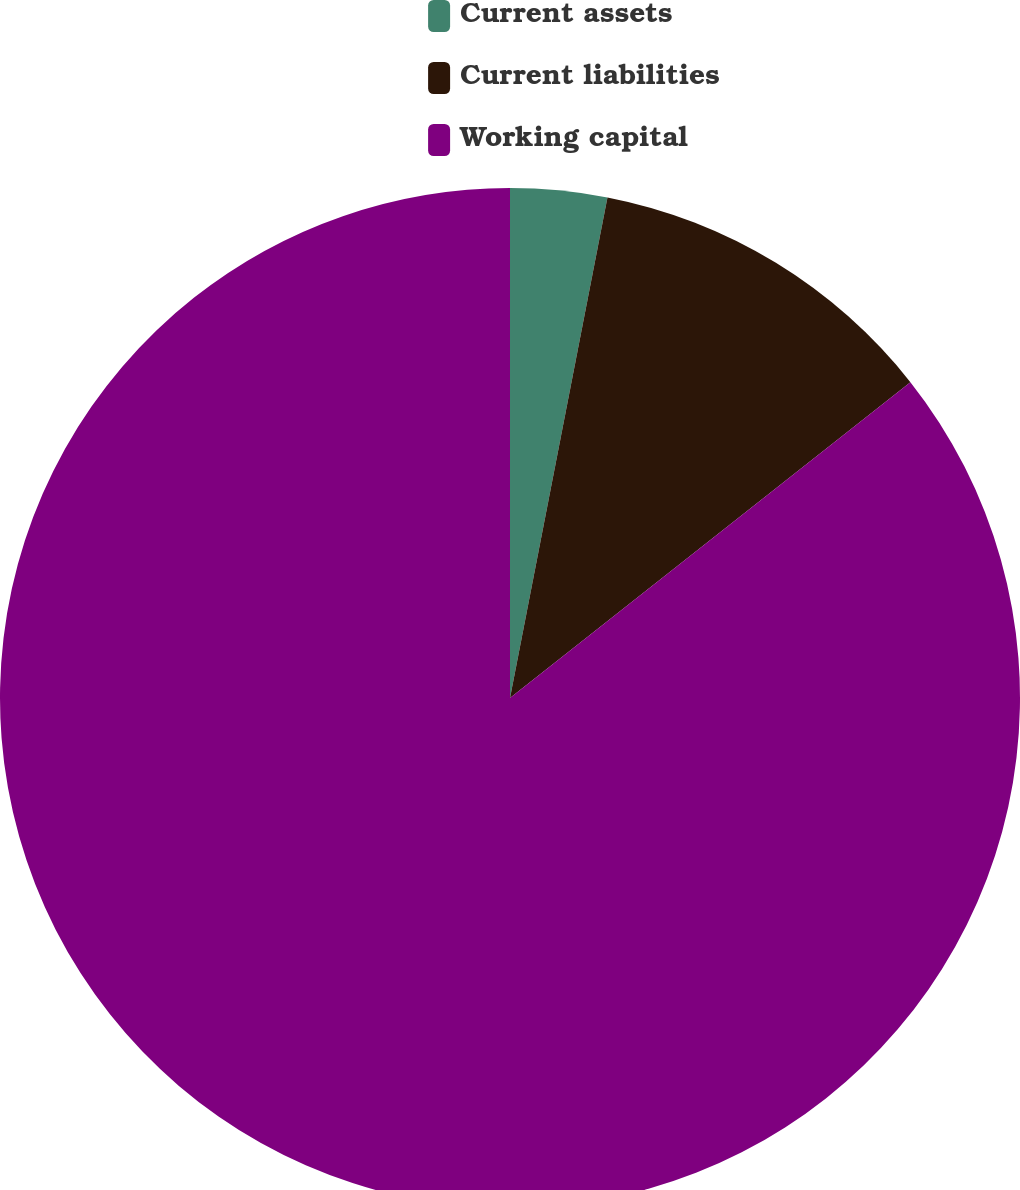Convert chart. <chart><loc_0><loc_0><loc_500><loc_500><pie_chart><fcel>Current assets<fcel>Current liabilities<fcel>Working capital<nl><fcel>3.06%<fcel>11.31%<fcel>85.63%<nl></chart> 